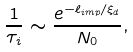<formula> <loc_0><loc_0><loc_500><loc_500>\frac { 1 } { \tau _ { i } } \sim \frac { e ^ { - \ell _ { i m p } / \xi _ { d } } } { N _ { 0 } } ,</formula> 